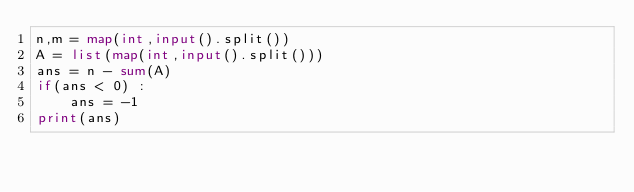Convert code to text. <code><loc_0><loc_0><loc_500><loc_500><_Python_>n,m = map(int,input().split())
A = list(map(int,input().split()))
ans = n - sum(A)
if(ans < 0) :
    ans = -1
print(ans)</code> 